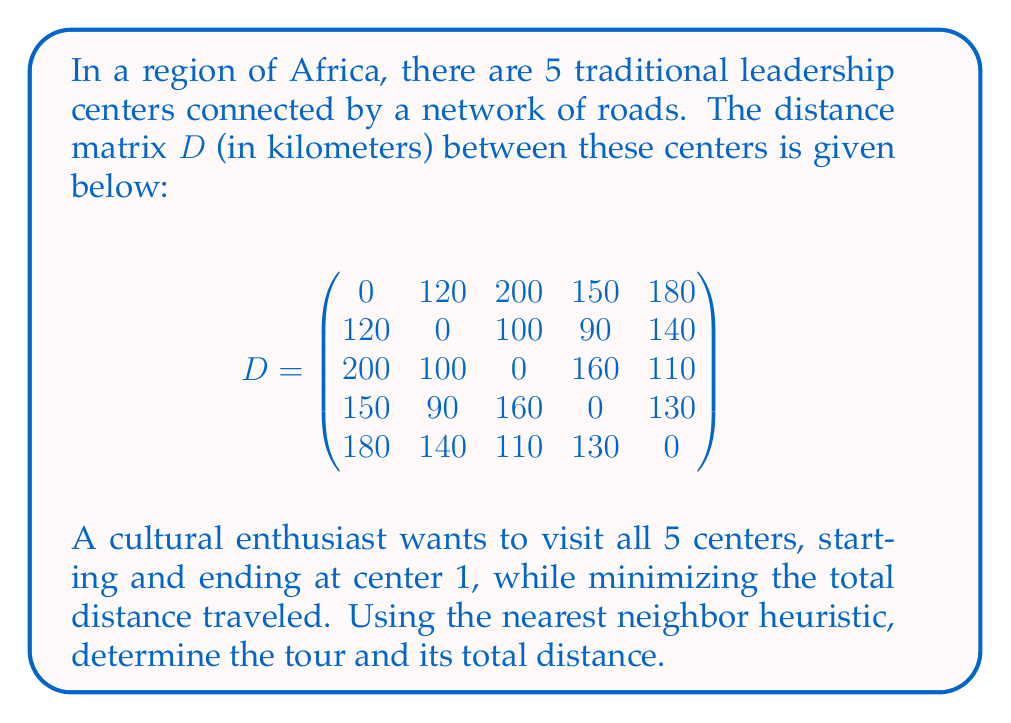What is the answer to this math problem? To solve this problem using the nearest neighbor heuristic, we follow these steps:

1) Start at center 1.
2) Find the nearest unvisited center and move to it.
3) Repeat step 2 until all centers are visited.
4) Return to center 1.

Let's apply this algorithm:

1) We start at center 1.

2) From center 1, the nearest center is 2 (120 km). Move to center 2.
   Tour so far: 1 - 2
   Distance: 120 km

3) From center 2, the nearest unvisited center is 4 (90 km). Move to center 4.
   Tour so far: 1 - 2 - 4
   Distance: 120 + 90 = 210 km

4) From center 4, the nearest unvisited center is 5 (130 km). Move to center 5.
   Tour so far: 1 - 2 - 4 - 5
   Distance: 210 + 130 = 340 km

5) From center 5, the only unvisited center is 3 (110 km). Move to center 3.
   Tour so far: 1 - 2 - 4 - 5 - 3
   Distance: 340 + 110 = 450 km

6) Finally, return to center 1 from center 3 (200 km).
   Complete tour: 1 - 2 - 4 - 5 - 3 - 1
   Total distance: 450 + 200 = 650 km

Therefore, the tour found by the nearest neighbor heuristic is 1 - 2 - 4 - 5 - 3 - 1, with a total distance of 650 km.
Answer: The tour: 1 - 2 - 4 - 5 - 3 - 1
Total distance: 650 km 